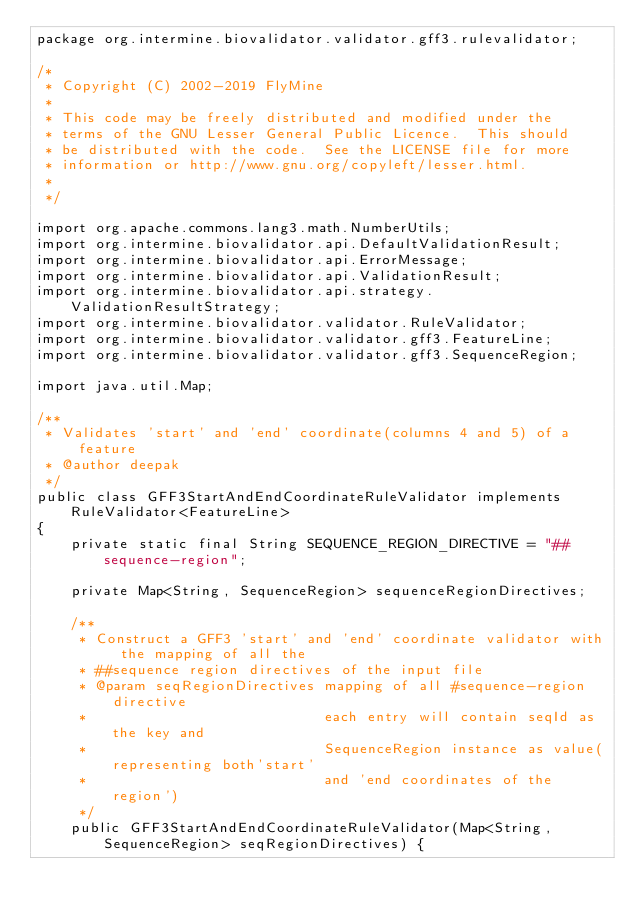Convert code to text. <code><loc_0><loc_0><loc_500><loc_500><_Java_>package org.intermine.biovalidator.validator.gff3.rulevalidator;

/*
 * Copyright (C) 2002-2019 FlyMine
 *
 * This code may be freely distributed and modified under the
 * terms of the GNU Lesser General Public Licence.  This should
 * be distributed with the code.  See the LICENSE file for more
 * information or http://www.gnu.org/copyleft/lesser.html.
 *
 */

import org.apache.commons.lang3.math.NumberUtils;
import org.intermine.biovalidator.api.DefaultValidationResult;
import org.intermine.biovalidator.api.ErrorMessage;
import org.intermine.biovalidator.api.ValidationResult;
import org.intermine.biovalidator.api.strategy.ValidationResultStrategy;
import org.intermine.biovalidator.validator.RuleValidator;
import org.intermine.biovalidator.validator.gff3.FeatureLine;
import org.intermine.biovalidator.validator.gff3.SequenceRegion;

import java.util.Map;

/**
 * Validates 'start' and 'end' coordinate(columns 4 and 5) of a feature
 * @author deepak
 */
public class GFF3StartAndEndCoordinateRuleValidator implements RuleValidator<FeatureLine>
{
    private static final String SEQUENCE_REGION_DIRECTIVE = "##sequence-region";

    private Map<String, SequenceRegion> sequenceRegionDirectives;

    /**
     * Construct a GFF3 'start' and 'end' coordinate validator with the mapping of all the
     * ##sequence region directives of the input file
     * @param seqRegionDirectives mapping of all #sequence-region directive
     *                            each entry will contain seqId as the key and
     *                            SequenceRegion instance as value(representing both'start'
     *                            and 'end coordinates of the region')
     */
    public GFF3StartAndEndCoordinateRuleValidator(Map<String, SequenceRegion> seqRegionDirectives) {</code> 